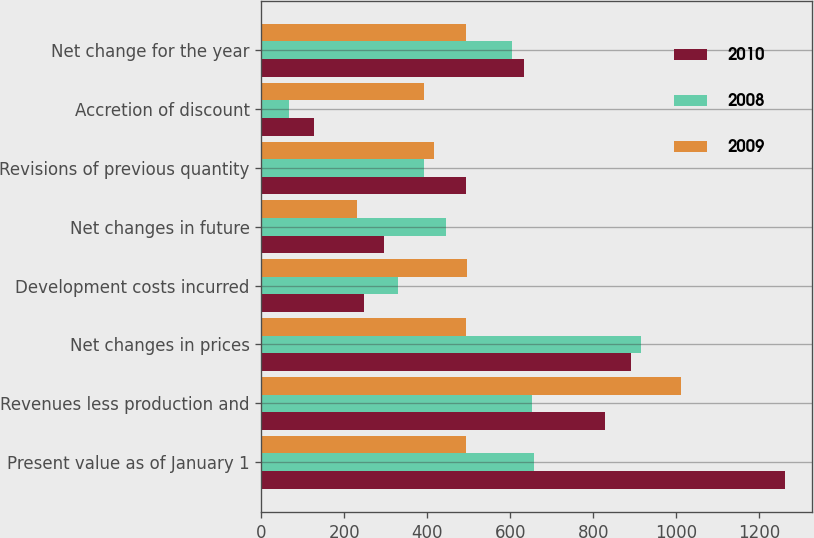<chart> <loc_0><loc_0><loc_500><loc_500><stacked_bar_chart><ecel><fcel>Present value as of January 1<fcel>Revenues less production and<fcel>Net changes in prices<fcel>Development costs incurred<fcel>Net changes in future<fcel>Revisions of previous quantity<fcel>Accretion of discount<fcel>Net change for the year<nl><fcel>2010<fcel>1263.3<fcel>828.2<fcel>890<fcel>248<fcel>296.6<fcel>494.2<fcel>126.9<fcel>634.3<nl><fcel>2008<fcel>658.4<fcel>652.7<fcel>915.7<fcel>330.3<fcel>445.4<fcel>391.1<fcel>65.9<fcel>604.9<nl><fcel>2009<fcel>494.2<fcel>1012.4<fcel>494.2<fcel>495.2<fcel>231.1<fcel>417.1<fcel>392.9<fcel>494.2<nl></chart> 